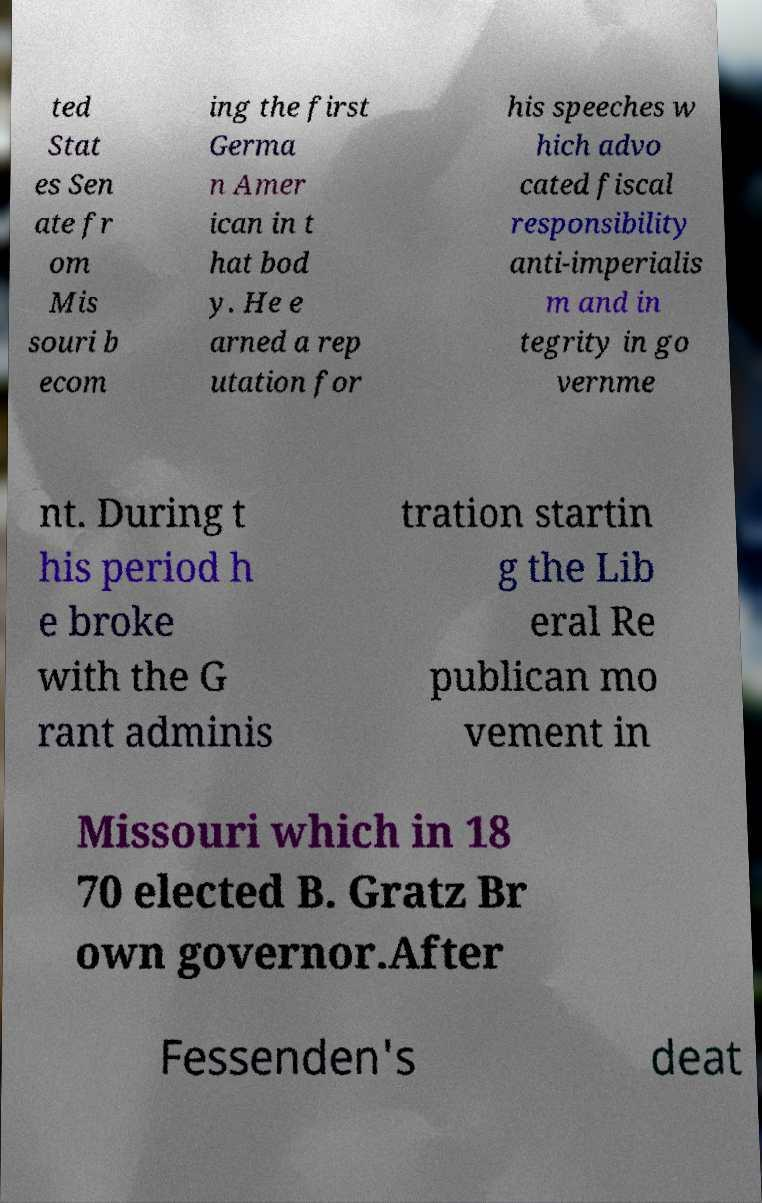Can you read and provide the text displayed in the image?This photo seems to have some interesting text. Can you extract and type it out for me? ted Stat es Sen ate fr om Mis souri b ecom ing the first Germa n Amer ican in t hat bod y. He e arned a rep utation for his speeches w hich advo cated fiscal responsibility anti-imperialis m and in tegrity in go vernme nt. During t his period h e broke with the G rant adminis tration startin g the Lib eral Re publican mo vement in Missouri which in 18 70 elected B. Gratz Br own governor.After Fessenden's deat 